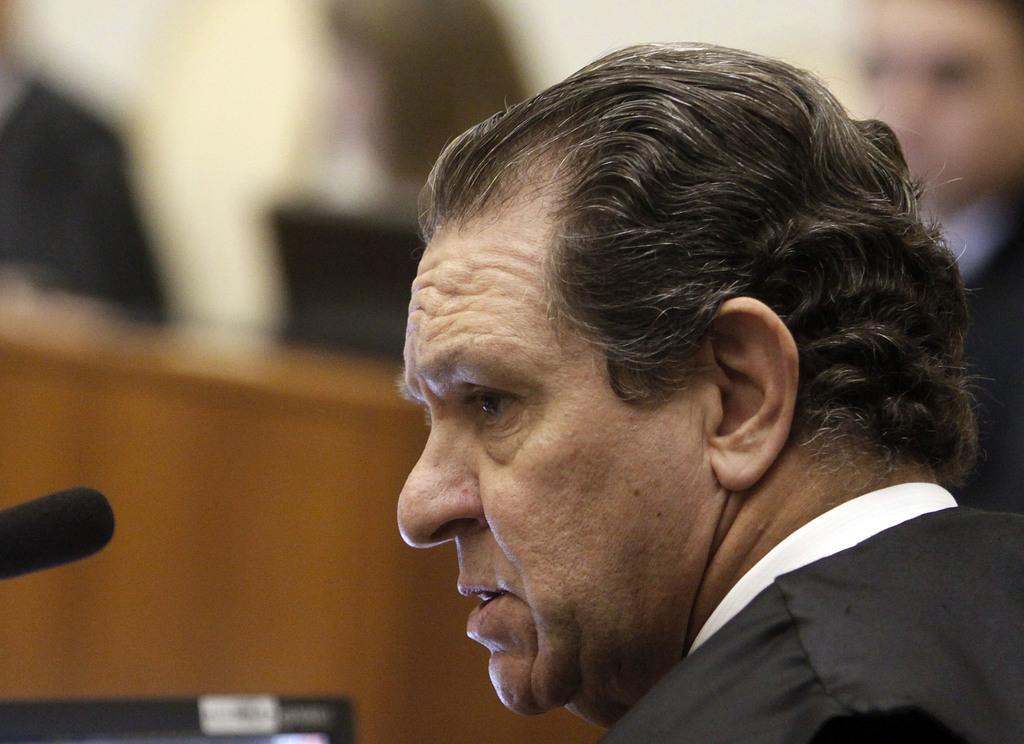What is the main subject in the foreground of the image? There is a person in the foreground of the image. What is the person doing in the image? The person is talking. What object is present that might be related to the person's activity? There is a microphone (mike) in the image. What can be seen at the bottom of the image? There is a screen at the bottom of the image. How would you describe the background of the image? The background of the image is blurry. What type of doctor can be seen examining the knee in the image? There is no doctor or knee present in the image. How many ears of corn are visible on the screen at the bottom of the image? There are no ears of corn visible on the screen at the bottom of the image. 